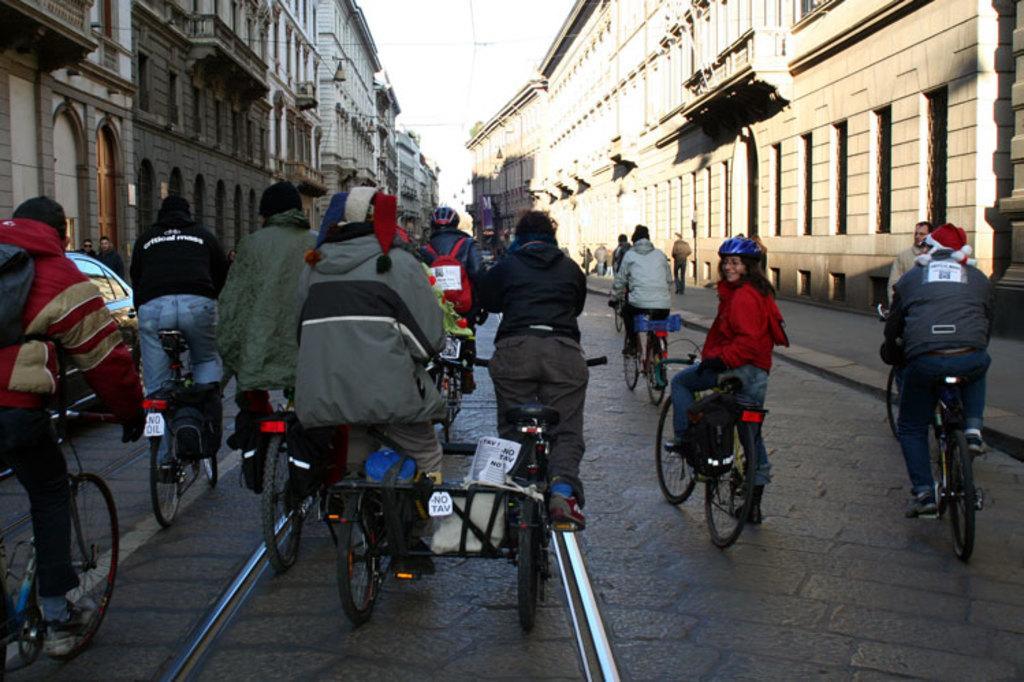Can you describe this image briefly? As we can see in the image there is a sky, buildings and few of them are riding bicycles on road. 